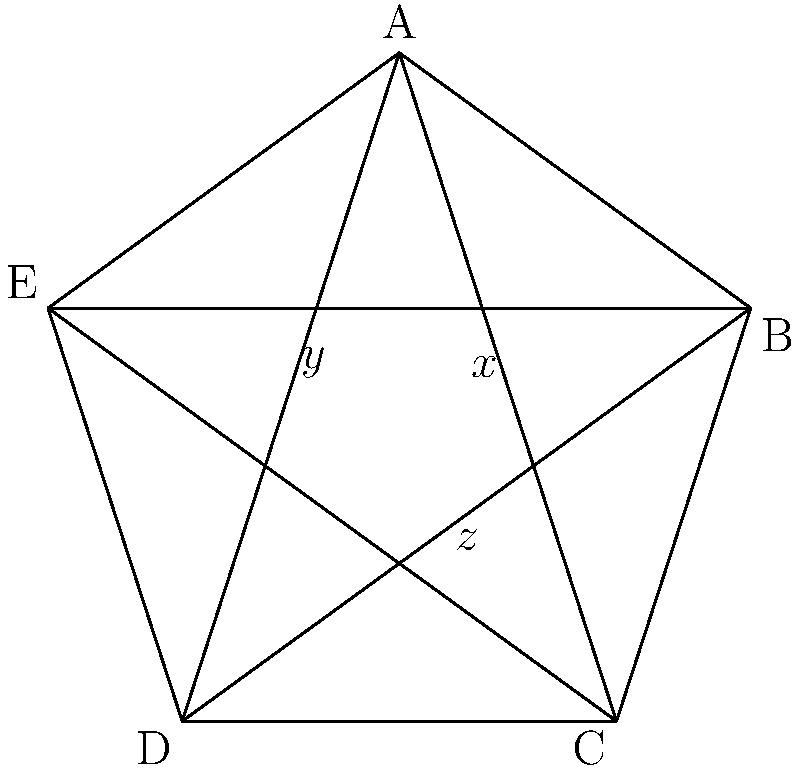In a regular pentagram, as shown in the figure, angles $x$, $y$, and $z$ are formed by the intersecting lines. If the measure of angle $x$ is 36°, what is the sum of the measures of angles $y$ and $z$? Let's approach this step-by-step:

1) In a regular pentagram, all the angles at the vertices are equal. Each vertex angle measures $36°$.

2) The angle $x$ is formed by two lines that connect non-adjacent vertices of the pentagon. This angle is supplementary to the vertex angle. Therefore:
   
   $x + 36° = 180°$
   $x = 144°$

3) We're given that $x = 36°$. This means that the pentagram in the question is not regular, but let's continue with this information.

4) In any pentagram, regular or not, the sum of the angles formed at the intersections of the lines is constant and equal to $180°$. This is because these angles form a line when the pentagram is unfolded.

5) Therefore:

   $x + y + z = 180°$

6) Substituting the known value of $x$:

   $36° + y + z = 180°$

7) Solving for $y + z$:

   $y + z = 180° - 36° = 144°$

Thus, the sum of angles $y$ and $z$ is $144°$.
Answer: $144°$ 